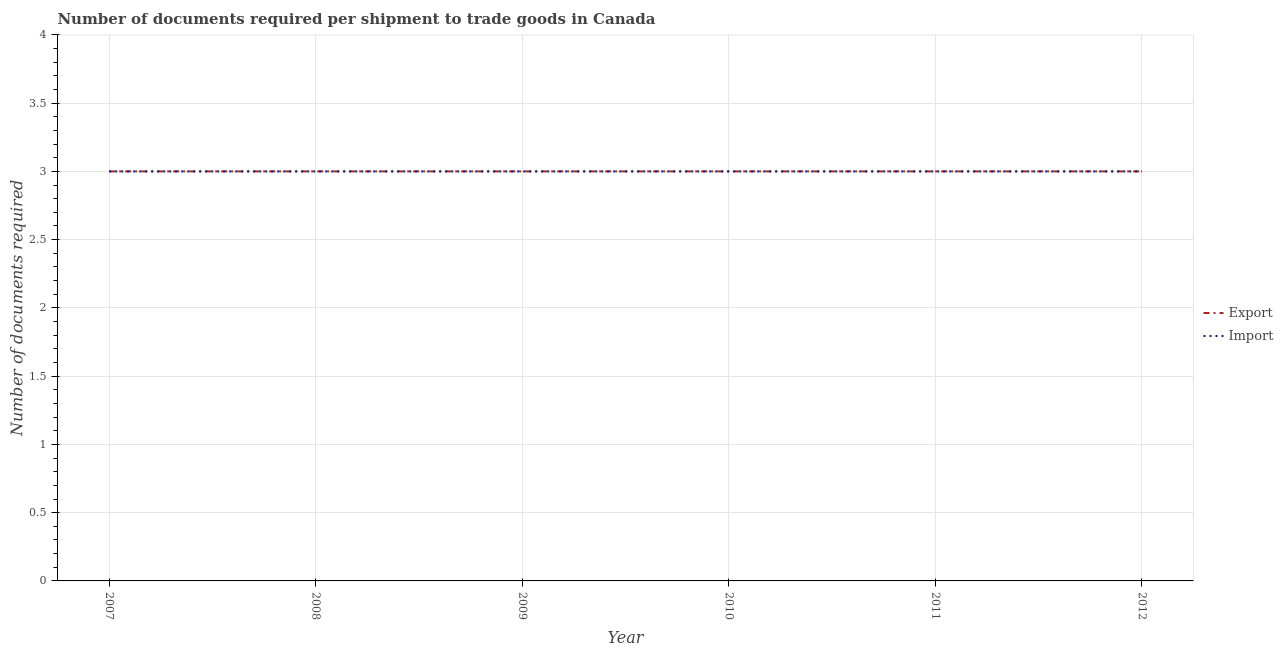How many different coloured lines are there?
Ensure brevity in your answer.  2. Does the line corresponding to number of documents required to import goods intersect with the line corresponding to number of documents required to export goods?
Provide a short and direct response. Yes. Is the number of lines equal to the number of legend labels?
Offer a very short reply. Yes. What is the number of documents required to export goods in 2011?
Provide a succinct answer. 3. Across all years, what is the maximum number of documents required to import goods?
Your answer should be very brief. 3. Across all years, what is the minimum number of documents required to export goods?
Give a very brief answer. 3. In which year was the number of documents required to import goods maximum?
Your answer should be compact. 2007. What is the total number of documents required to export goods in the graph?
Provide a short and direct response. 18. What is the average number of documents required to export goods per year?
Provide a succinct answer. 3. In how many years, is the number of documents required to import goods greater than 2.9?
Your response must be concise. 6. Is the difference between the number of documents required to import goods in 2008 and 2009 greater than the difference between the number of documents required to export goods in 2008 and 2009?
Give a very brief answer. No. What is the difference between the highest and the lowest number of documents required to import goods?
Provide a succinct answer. 0. In how many years, is the number of documents required to import goods greater than the average number of documents required to import goods taken over all years?
Your response must be concise. 0. Does the number of documents required to export goods monotonically increase over the years?
Your response must be concise. No. Is the number of documents required to export goods strictly greater than the number of documents required to import goods over the years?
Offer a very short reply. No. Is the number of documents required to import goods strictly less than the number of documents required to export goods over the years?
Provide a succinct answer. No. How many lines are there?
Your response must be concise. 2. How many years are there in the graph?
Offer a very short reply. 6. Does the graph contain any zero values?
Provide a succinct answer. No. Does the graph contain grids?
Offer a very short reply. Yes. Where does the legend appear in the graph?
Offer a terse response. Center right. How are the legend labels stacked?
Offer a terse response. Vertical. What is the title of the graph?
Ensure brevity in your answer.  Number of documents required per shipment to trade goods in Canada. What is the label or title of the X-axis?
Provide a short and direct response. Year. What is the label or title of the Y-axis?
Make the answer very short. Number of documents required. What is the Number of documents required of Import in 2007?
Keep it short and to the point. 3. What is the Number of documents required in Export in 2008?
Offer a terse response. 3. What is the Number of documents required of Import in 2008?
Offer a terse response. 3. What is the Number of documents required of Export in 2010?
Provide a short and direct response. 3. What is the Number of documents required of Import in 2010?
Your answer should be compact. 3. What is the Number of documents required in Export in 2011?
Your answer should be very brief. 3. What is the Number of documents required of Import in 2012?
Provide a succinct answer. 3. Across all years, what is the maximum Number of documents required in Export?
Your answer should be compact. 3. Across all years, what is the maximum Number of documents required of Import?
Your response must be concise. 3. What is the total Number of documents required of Export in the graph?
Provide a succinct answer. 18. What is the difference between the Number of documents required in Import in 2007 and that in 2009?
Your response must be concise. 0. What is the difference between the Number of documents required in Export in 2007 and that in 2010?
Offer a terse response. 0. What is the difference between the Number of documents required in Export in 2007 and that in 2011?
Your answer should be compact. 0. What is the difference between the Number of documents required in Import in 2007 and that in 2011?
Your answer should be compact. 0. What is the difference between the Number of documents required in Import in 2007 and that in 2012?
Keep it short and to the point. 0. What is the difference between the Number of documents required in Export in 2008 and that in 2009?
Keep it short and to the point. 0. What is the difference between the Number of documents required of Import in 2008 and that in 2010?
Provide a succinct answer. 0. What is the difference between the Number of documents required of Export in 2008 and that in 2011?
Your response must be concise. 0. What is the difference between the Number of documents required of Import in 2008 and that in 2011?
Offer a terse response. 0. What is the difference between the Number of documents required of Import in 2009 and that in 2010?
Offer a terse response. 0. What is the difference between the Number of documents required in Export in 2009 and that in 2011?
Your response must be concise. 0. What is the difference between the Number of documents required in Import in 2009 and that in 2011?
Make the answer very short. 0. What is the difference between the Number of documents required in Export in 2009 and that in 2012?
Keep it short and to the point. 0. What is the difference between the Number of documents required of Import in 2010 and that in 2012?
Make the answer very short. 0. What is the difference between the Number of documents required of Export in 2007 and the Number of documents required of Import in 2009?
Offer a terse response. 0. What is the difference between the Number of documents required of Export in 2007 and the Number of documents required of Import in 2012?
Offer a very short reply. 0. What is the difference between the Number of documents required in Export in 2008 and the Number of documents required in Import in 2009?
Your answer should be very brief. 0. What is the difference between the Number of documents required in Export in 2008 and the Number of documents required in Import in 2011?
Ensure brevity in your answer.  0. What is the difference between the Number of documents required in Export in 2008 and the Number of documents required in Import in 2012?
Give a very brief answer. 0. What is the difference between the Number of documents required in Export in 2009 and the Number of documents required in Import in 2011?
Your answer should be compact. 0. What is the difference between the Number of documents required in Export in 2009 and the Number of documents required in Import in 2012?
Provide a short and direct response. 0. What is the difference between the Number of documents required of Export in 2011 and the Number of documents required of Import in 2012?
Keep it short and to the point. 0. In the year 2009, what is the difference between the Number of documents required in Export and Number of documents required in Import?
Your answer should be very brief. 0. In the year 2012, what is the difference between the Number of documents required in Export and Number of documents required in Import?
Make the answer very short. 0. What is the ratio of the Number of documents required of Export in 2007 to that in 2008?
Ensure brevity in your answer.  1. What is the ratio of the Number of documents required of Import in 2007 to that in 2008?
Your answer should be compact. 1. What is the ratio of the Number of documents required of Export in 2007 to that in 2009?
Your answer should be compact. 1. What is the ratio of the Number of documents required in Import in 2007 to that in 2009?
Ensure brevity in your answer.  1. What is the ratio of the Number of documents required in Export in 2007 to that in 2010?
Provide a succinct answer. 1. What is the ratio of the Number of documents required of Import in 2007 to that in 2010?
Offer a very short reply. 1. What is the ratio of the Number of documents required of Export in 2007 to that in 2011?
Ensure brevity in your answer.  1. What is the ratio of the Number of documents required of Import in 2007 to that in 2011?
Your response must be concise. 1. What is the ratio of the Number of documents required of Export in 2007 to that in 2012?
Your response must be concise. 1. What is the ratio of the Number of documents required of Export in 2008 to that in 2009?
Your response must be concise. 1. What is the ratio of the Number of documents required in Import in 2008 to that in 2009?
Make the answer very short. 1. What is the ratio of the Number of documents required in Import in 2008 to that in 2010?
Offer a terse response. 1. What is the ratio of the Number of documents required of Export in 2009 to that in 2010?
Offer a very short reply. 1. What is the ratio of the Number of documents required of Import in 2009 to that in 2010?
Offer a very short reply. 1. What is the ratio of the Number of documents required of Export in 2009 to that in 2011?
Offer a terse response. 1. What is the ratio of the Number of documents required of Import in 2009 to that in 2011?
Provide a short and direct response. 1. What is the ratio of the Number of documents required of Export in 2009 to that in 2012?
Your answer should be very brief. 1. What is the ratio of the Number of documents required in Import in 2009 to that in 2012?
Your answer should be very brief. 1. What is the ratio of the Number of documents required in Export in 2010 to that in 2011?
Provide a succinct answer. 1. What is the ratio of the Number of documents required in Import in 2010 to that in 2011?
Keep it short and to the point. 1. What is the ratio of the Number of documents required in Export in 2010 to that in 2012?
Provide a succinct answer. 1. What is the difference between the highest and the second highest Number of documents required in Import?
Your answer should be very brief. 0. 